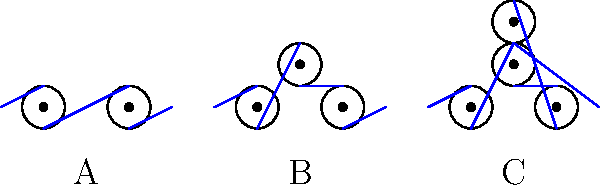As a psychologist conducting IQ tests, you encounter a question about pulley systems. Which of the pulley configurations (A, B, or C) provides the highest mechanical advantage, assuming ideal conditions with no friction? To determine the mechanical advantage of each pulley system, we need to analyze the number of rope segments supporting the load:

1. System A:
   - It has two pulleys, but only one rope segment supports the load.
   - Mechanical Advantage (MA) = 1

2. System B:
   - It has three pulleys with two rope segments supporting the load.
   - MA = 2

3. System C:
   - It has four pulleys with three rope segments supporting the load.
   - MA = 3

The mechanical advantage is calculated by counting the number of rope segments that support the load, excluding the segment where the force is applied.

In an ideal pulley system:
$$ \text{Mechanical Advantage} = \frac{\text{Load Force}}{\text{Effort Force}} = \text{Number of supporting rope segments} $$

Therefore, System C provides the highest mechanical advantage of 3, meaning it requires only 1/3 of the effort force compared to the load force.
Answer: C 